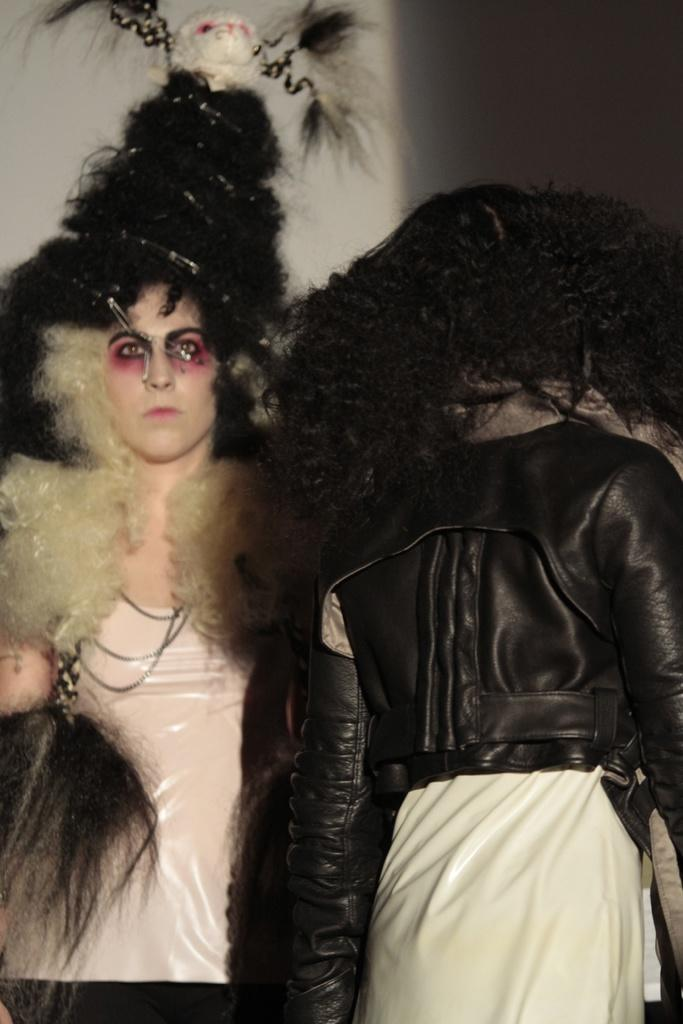How many people are present in the image? There are two people in the image. What can be seen in the background of the image? The background of the image is white. What type of wine is being served in the park in the image? There is no wine or park present in the image; it only features two people with a white background. 